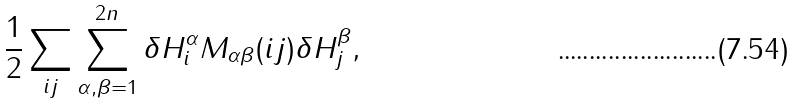<formula> <loc_0><loc_0><loc_500><loc_500>\frac { 1 } { 2 } \sum _ { i j } \sum _ { \alpha , \beta = 1 } ^ { 2 n } \delta H _ { i } ^ { \alpha } M _ { \alpha \beta } ( i j ) \delta H _ { j } ^ { \beta } ,</formula> 